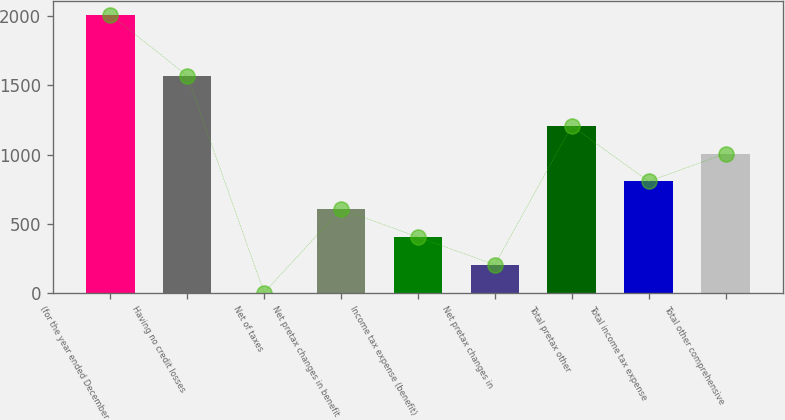Convert chart to OTSL. <chart><loc_0><loc_0><loc_500><loc_500><bar_chart><fcel>(for the year ended December<fcel>Having no credit losses<fcel>Net of taxes<fcel>Net pretax changes in benefit<fcel>Income tax expense (benefit)<fcel>Net pretax changes in<fcel>Total pretax other<fcel>Total income tax expense<fcel>Total other comprehensive<nl><fcel>2011<fcel>1570<fcel>2<fcel>604.7<fcel>403.8<fcel>202.9<fcel>1207.4<fcel>805.6<fcel>1006.5<nl></chart> 